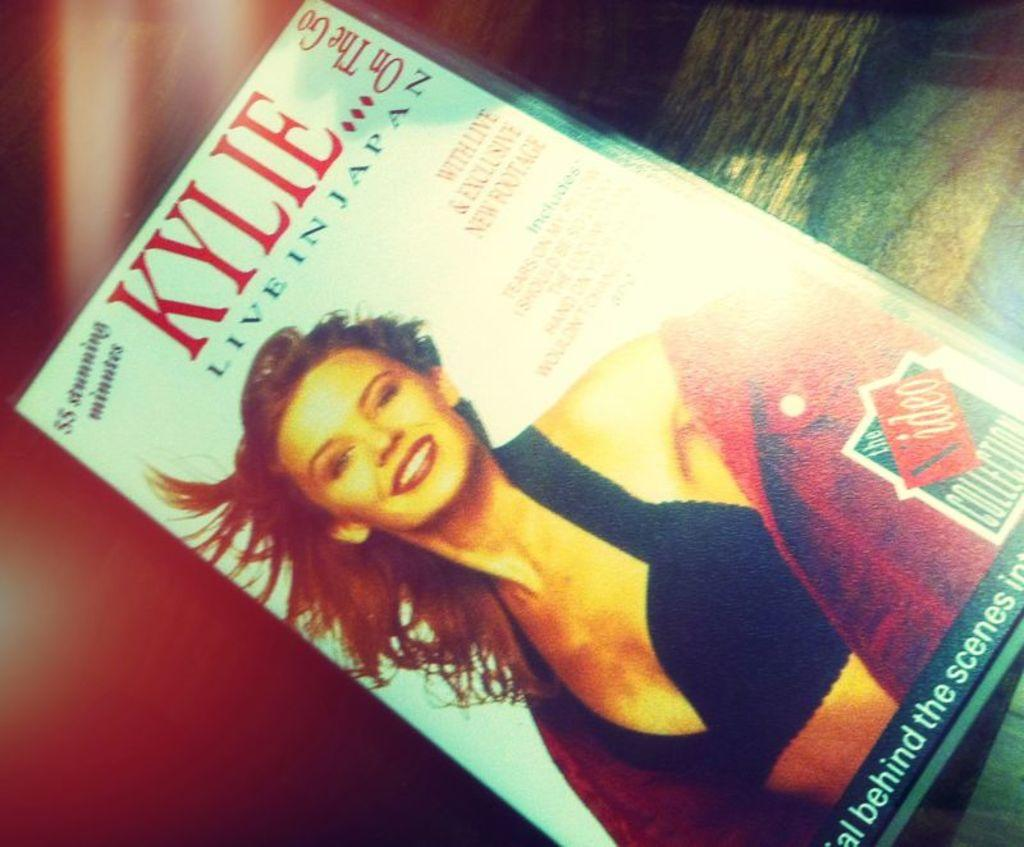What object is the main focus of the picture? There is a book in the picture. Can you describe the background of the image? The background is red and blurred. What color and location can be identified in the top right corner of the image? There is a green element in the right top of the picture. How many pieces of money are scattered around the book in the image? There is no money present in the image; it only features a book and a red, blurred background. What type of basket is placed next to the book in the image? There is no basket present in the image; it only features a book, a red, blurred background, and a green element in the top right corner. 